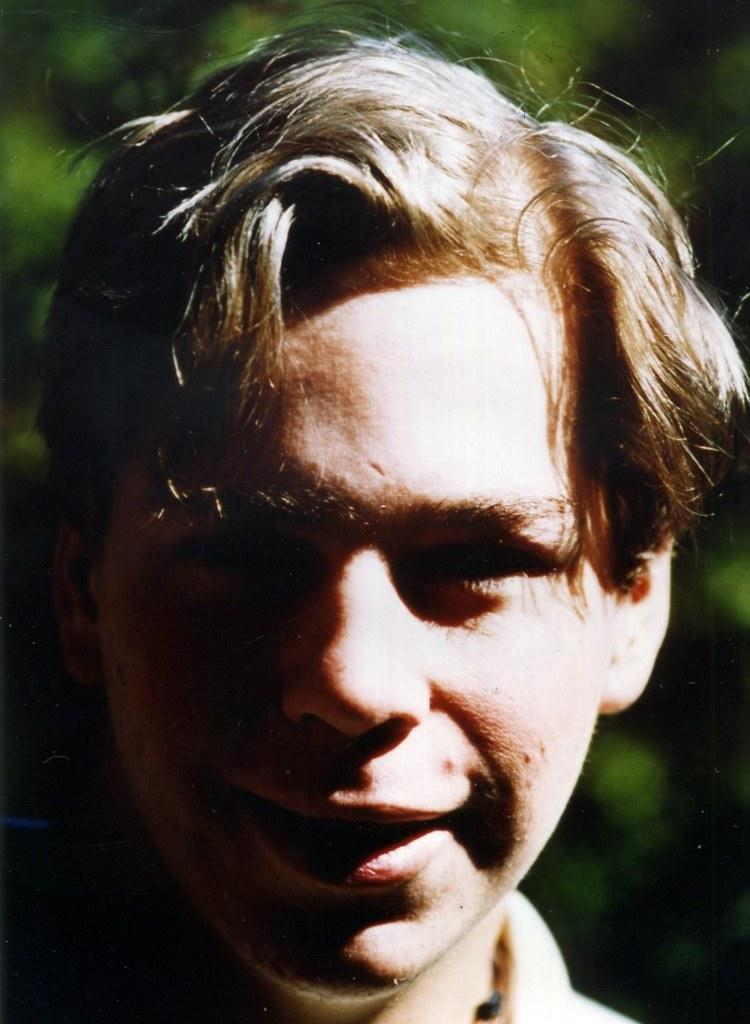Who is the main subject in the image? There is a boy in the image. What can be seen on the boy's face? The boy's face is in close view. What is the boy's expression in the image? The boy is smiling. What is the boy doing in the image? The boy is giving a pose to the camera. How is the background of the image depicted? The background of the image is green and blurred. How many cats are visible in the image? There are no cats present in the image; it features a boy posing for the camera. What type of pipe is the baby holding in the image? There is no baby or pipe present in the image. 